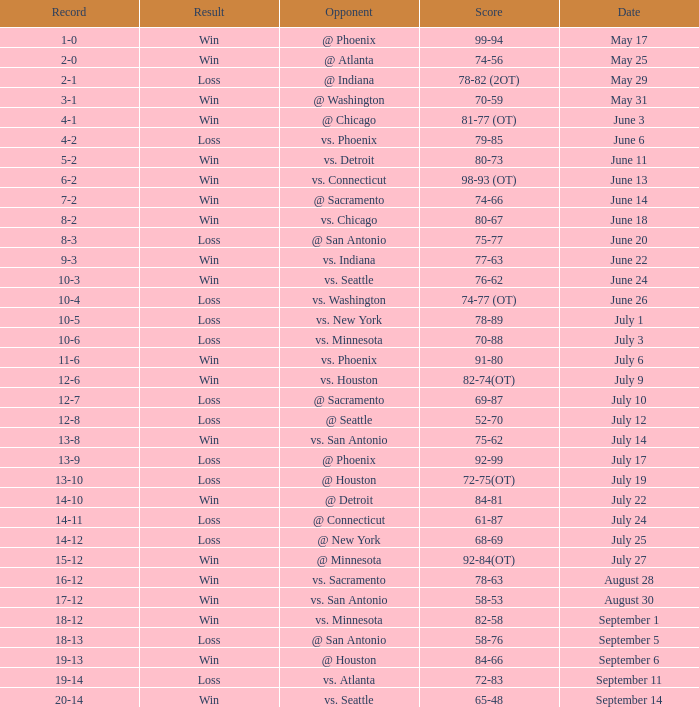What is the Record of the game on September 6? 19-13. 